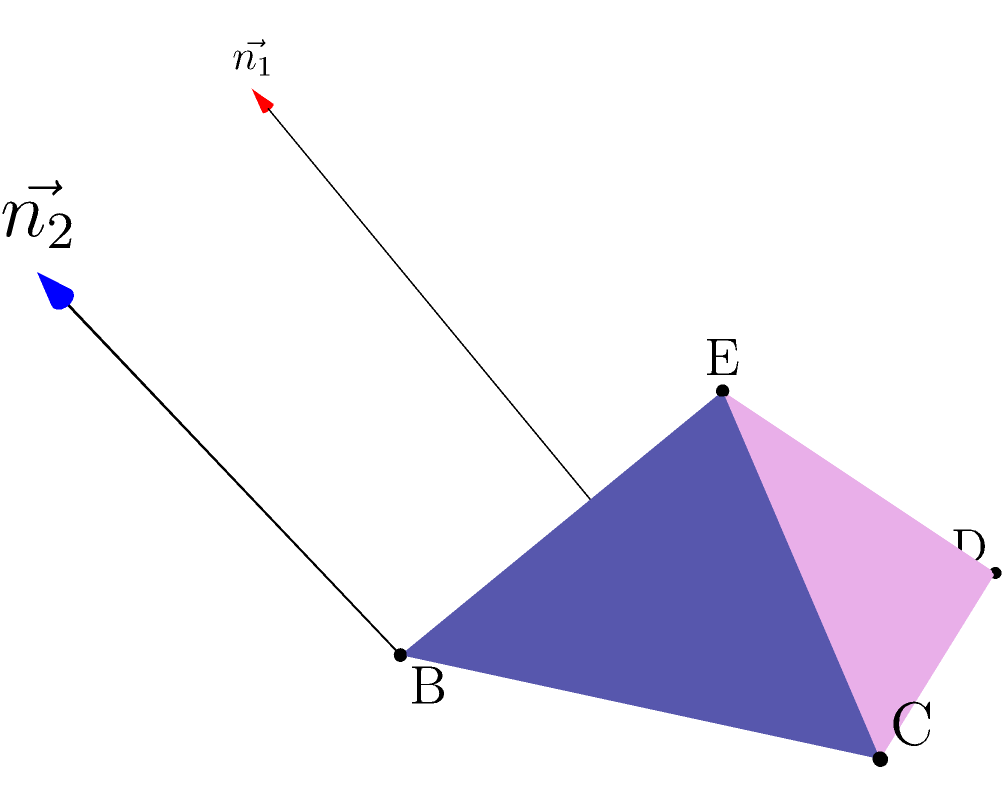In this folded paper artwork design, a square sheet of paper ABCD is folded to form a pyramid with apex E. The fold lines are AE, BE, CE, and DE. Given that AB = BC = CD = DA = 2 units and AE = BE = CE = DE = $\sqrt{3}$ units, calculate the angle between the planes ABE and BCE. To find the angle between two planes, we need to calculate the angle between their normal vectors. Let's approach this step-by-step:

1) First, we need to find the normal vectors to planes ABE and BCE.

   For plane ABE: $\vec{n_1} = \vec{AB} \times \vec{AE}$
   For plane BCE: $\vec{n_2} = \vec{BC} \times \vec{BE}$

2) Let's calculate these vectors:
   $\vec{AB} = (2,0,0)$
   $\vec{AE} = (1,1,1)$
   $\vec{BC} = (0,2,0)$
   $\vec{BE} = (-1,1,1)$

3) Now, let's compute the cross products:
   $\vec{n_1} = \vec{AB} \times \vec{AE} = (0,2,-2)$
   $\vec{n_2} = \vec{BC} \times \vec{BE} = (-2,0,-2)$

4) The angle $\theta$ between these normal vectors is given by the dot product formula:

   $$\cos \theta = \frac{\vec{n_1} \cdot \vec{n_2}}{|\vec{n_1}||\vec{n_2}|}$$

5) Calculate the dot product:
   $\vec{n_1} \cdot \vec{n_2} = (0)(−2) + (2)(0) + (−2)(−2) = 4$

6) Calculate the magnitudes:
   $|\vec{n_1}| = \sqrt{0^2 + 2^2 + (-2)^2} = 2\sqrt{2}$
   $|\vec{n_2}| = \sqrt{(-2)^2 + 0^2 + (-2)^2} = 2\sqrt{2}$

7) Substitute into the formula:
   $$\cos \theta = \frac{4}{(2\sqrt{2})(2\sqrt{2})} = \frac{4}{8} = \frac{1}{2}$$

8) Therefore:
   $$\theta = \arccos(\frac{1}{2}) = 60°$$

The angle between the planes ABE and BCE is 60°.
Answer: 60° 